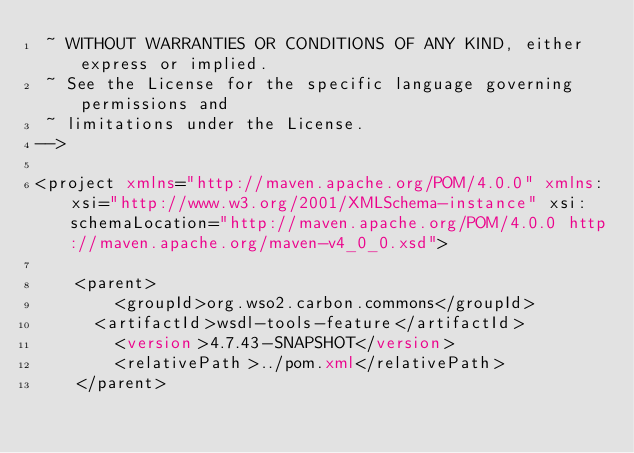<code> <loc_0><loc_0><loc_500><loc_500><_XML_> ~ WITHOUT WARRANTIES OR CONDITIONS OF ANY KIND, either express or implied.
 ~ See the License for the specific language governing permissions and
 ~ limitations under the License.
-->
        
<project xmlns="http://maven.apache.org/POM/4.0.0" xmlns:xsi="http://www.w3.org/2001/XMLSchema-instance" xsi:schemaLocation="http://maven.apache.org/POM/4.0.0 http://maven.apache.org/maven-v4_0_0.xsd">

    <parent>
        <groupId>org.wso2.carbon.commons</groupId>
    	<artifactId>wsdl-tools-feature</artifactId>
        <version>4.7.43-SNAPSHOT</version>
        <relativePath>../pom.xml</relativePath>
    </parent>
</code> 